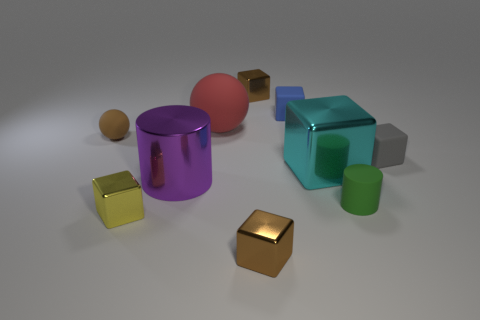How many other objects are the same color as the tiny sphere?
Your answer should be compact. 2. Is the blue cube made of the same material as the cylinder on the right side of the big purple cylinder?
Ensure brevity in your answer.  Yes. Is the number of brown rubber spheres in front of the large red object greater than the number of tiny yellow shiny things that are behind the large shiny cylinder?
Provide a short and direct response. Yes. What shape is the tiny blue object?
Give a very brief answer. Cube. Does the block right of the cyan cube have the same material as the tiny cube that is on the left side of the big metal cylinder?
Provide a succinct answer. No. There is a brown metal thing in front of the yellow metal cube; what is its shape?
Offer a terse response. Cube. What size is the yellow metal object that is the same shape as the tiny blue object?
Offer a terse response. Small. Does the small cylinder have the same color as the tiny rubber sphere?
Give a very brief answer. No. Is there anything else that has the same shape as the big rubber thing?
Provide a short and direct response. Yes. There is a rubber cube left of the green object; are there any small brown objects in front of it?
Give a very brief answer. Yes. 